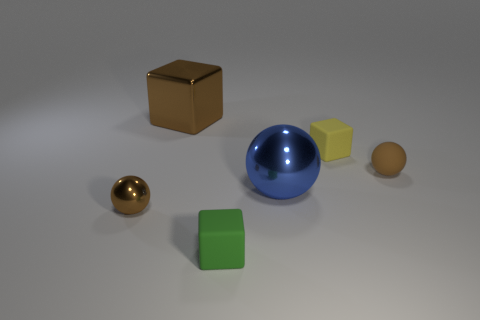Do the rubber object that is in front of the tiny brown shiny object and the blue metallic object have the same shape?
Provide a short and direct response. No. How many big brown objects have the same material as the blue object?
Provide a succinct answer. 1. How many things are either tiny objects behind the blue thing or small brown metal spheres?
Make the answer very short. 3. How big is the green rubber cube?
Offer a terse response. Small. There is a brown sphere that is to the right of the brown sphere that is in front of the large shiny ball; what is its material?
Your answer should be compact. Rubber. Do the shiny sphere that is in front of the blue sphere and the small green cube have the same size?
Offer a terse response. Yes. Are there any metal cylinders of the same color as the big metal cube?
Make the answer very short. No. How many objects are either small metallic objects in front of the yellow block or tiny brown things that are behind the blue thing?
Give a very brief answer. 2. Is the big metallic cube the same color as the tiny metal thing?
Your answer should be very brief. Yes. There is a big thing that is the same color as the small metallic thing; what material is it?
Keep it short and to the point. Metal. 